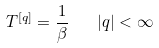<formula> <loc_0><loc_0><loc_500><loc_500>T ^ { [ q ] } = \frac { 1 } { \beta } \quad | q | < \infty</formula> 